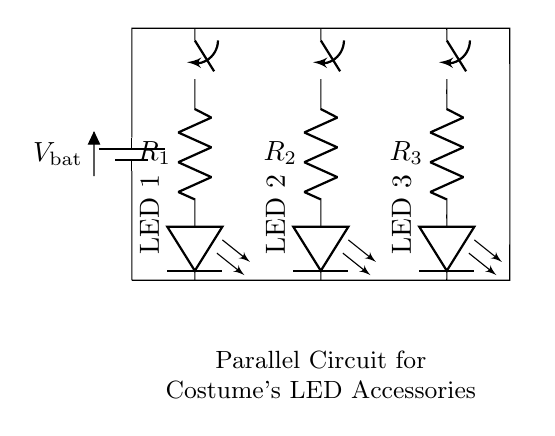What is the type of circuit shown? The circuit is a parallel circuit because multiple components (LEDs) are connected across the same voltage source, allowing each to operate independently.
Answer: parallel circuit How many resistors are in the circuit? There are three resistors in the circuit, as represented by R1, R2, and R3. Each resistor corresponds to one of the LEDs.
Answer: three What is the role of the switches in the circuit? The switches control the flow of current to each LED. If a switch is closed, the corresponding LED will light up; if open, it will not.
Answer: control current What will happen if one LED fails? If one LED fails (opens), the others will continue to operate because they are connected in parallel, ensuring the circuit remains functional.
Answer: remaining LEDs operate How does the voltage across each LED compare? The voltage across each LED is the same as the battery voltage because the components are arranged in a parallel configuration.
Answer: same as battery voltage What is the purpose of the resistors in this circuit? The resistors limit the current flowing through each LED to prevent them from burning out, ensuring safe operation.
Answer: limit current 